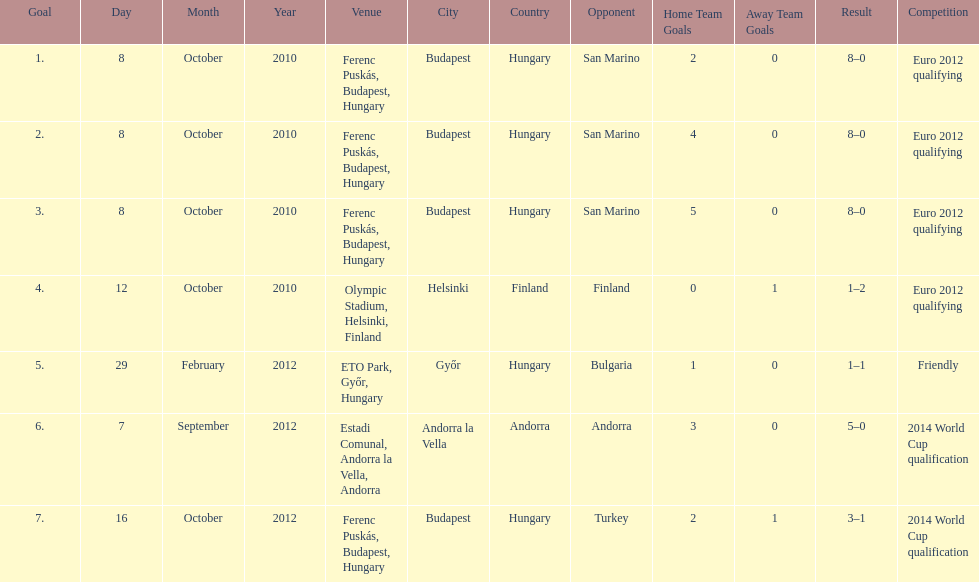How many consecutive games were goals were against san marino? 3. 